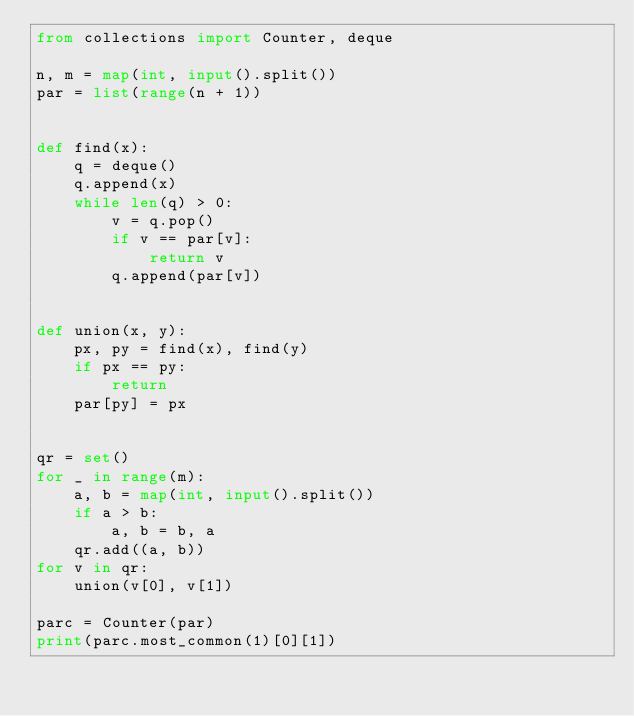<code> <loc_0><loc_0><loc_500><loc_500><_Python_>from collections import Counter, deque

n, m = map(int, input().split())
par = list(range(n + 1))


def find(x):
    q = deque()
    q.append(x)
    while len(q) > 0:
        v = q.pop()
        if v == par[v]:
            return v
        q.append(par[v])


def union(x, y):
    px, py = find(x), find(y)
    if px == py:
        return
    par[py] = px


qr = set()
for _ in range(m):
    a, b = map(int, input().split())
    if a > b:
        a, b = b, a
    qr.add((a, b))
for v in qr:
    union(v[0], v[1])

parc = Counter(par)
print(parc.most_common(1)[0][1])
</code> 